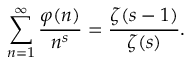<formula> <loc_0><loc_0><loc_500><loc_500>\sum _ { n = 1 } ^ { \infty } { \frac { \varphi ( n ) } { n ^ { s } } } = { \frac { \zeta ( s - 1 ) } { \zeta ( s ) } } .</formula> 